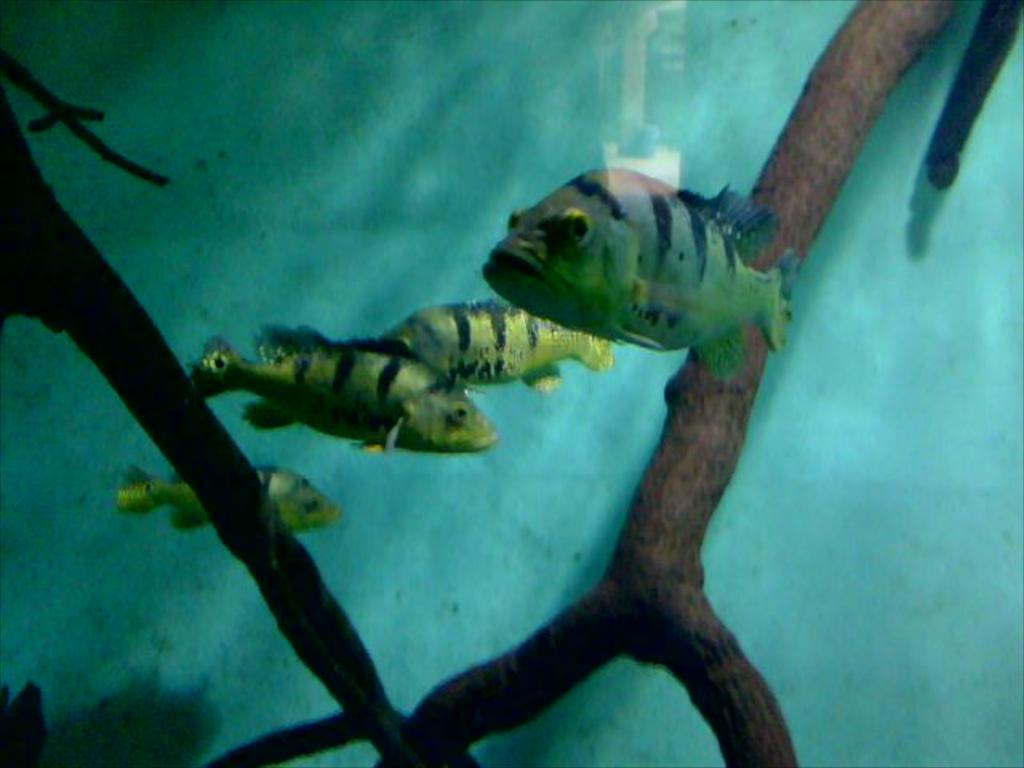What type of animals can be seen in the water in the image? There are fishes in the water in the image. How many fishes are visible in the water? There are four fishes in the water. What else can be seen in the image besides the fishes? There are plants visible in the image. What type of bean is growing on the fishes in the image? There are no beans present in the image, and the fishes are not growing anything. 